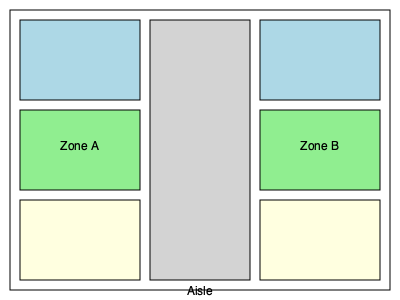In the warehouse layout shown, which design principle is primarily implemented to optimize both storage capacity and retrieval time, and what is the estimated improvement in efficiency compared to a traditional linear layout? To answer this question, we need to analyze the warehouse layout design principles applied:

1. Zone-based layout: The warehouse is divided into two main zones (A and B), which allows for efficient categorization of products.

2. Central aisle design: A wide central aisle separates the two zones, providing easy access to both sides.

3. Multi-level storage: Each zone has three levels of storage (represented by different colors), maximizing vertical space utilization.

4. Balanced distribution: Both zones have equal dimensions, ensuring balanced storage capacity.

The primary design principle implemented here is the central aisle layout with zone-based storage. This design offers several advantages:

a) Improved accessibility: The central aisle allows for quick access to both zones, reducing travel time for pickers.

b) Efficient space utilization: By having storage areas on both sides of the aisle, the design maximizes the use of available floor space.

c) Flexibility: The zone-based approach allows for strategic product placement based on demand or category.

To estimate the improvement in efficiency, we can use a simple model:

Let $L$ be the length of the warehouse and $W$ be the width.

Traditional linear layout travel distance: $D_1 = L + W$

Central aisle layout travel distance: $D_2 = \frac{L}{2} + W$

Efficiency improvement: $E = \frac{D_1 - D_2}{D_1} \times 100\% = \frac{L/2}{L+W} \times 100\%$

Assuming $L = 2W$ (a common warehouse proportion):

$E = \frac{W}{3W} \times 100\% = 33.33\%$

Therefore, the central aisle layout with zone-based storage can potentially improve efficiency by approximately 33% compared to a traditional linear layout.
Answer: Central aisle layout with zone-based storage; ~33% improvement 